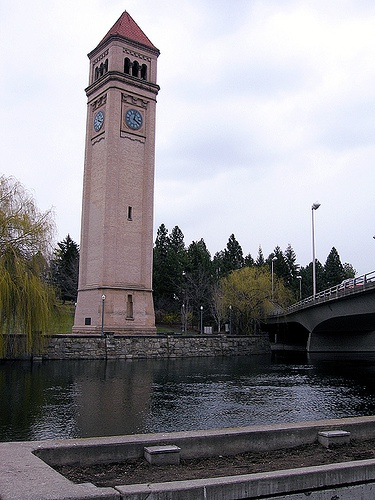Describe the objects in this image and their specific colors. I can see clock in lavender, gray, navy, and darkblue tones, car in lavender, black, gray, and darkgray tones, and clock in lavender, gray, darkgray, and blue tones in this image. 